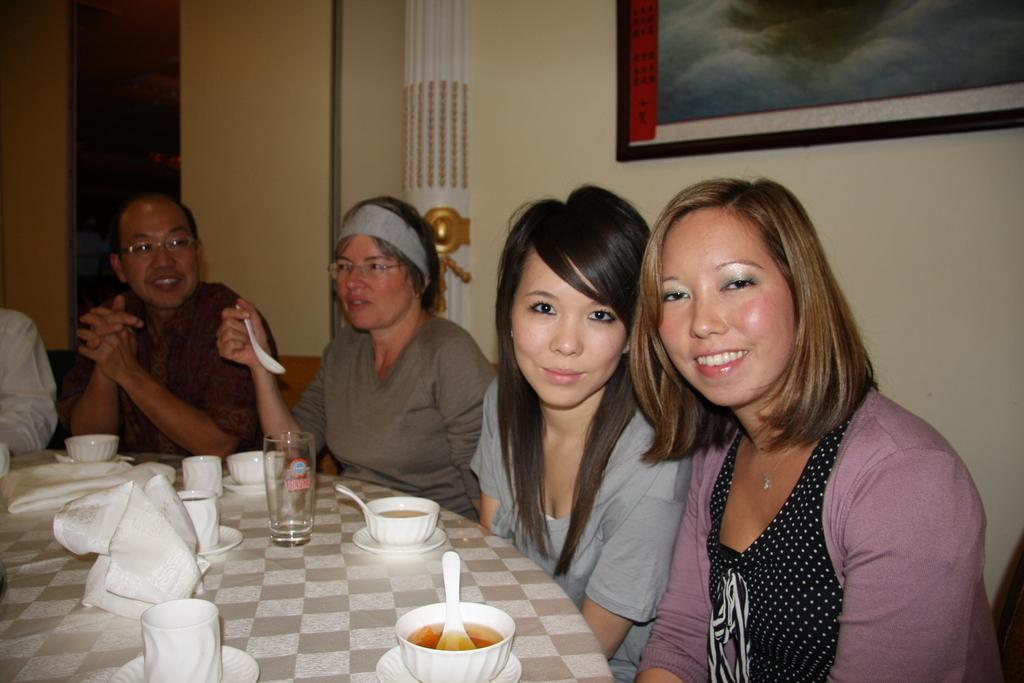How many people are in the image? There is a group of people in the image. What are the people doing in the image? The people are seated on chairs. What can be seen on the table in the image? There are cups with food and glasses on the table. What is on the wall in the image? There is a photo frame on the wall. What type of treatment is the robin receiving in the image? There is no robin present in the image, and therefore no treatment can be observed. How many geese are visible in the image? There are no geese present in the image. 